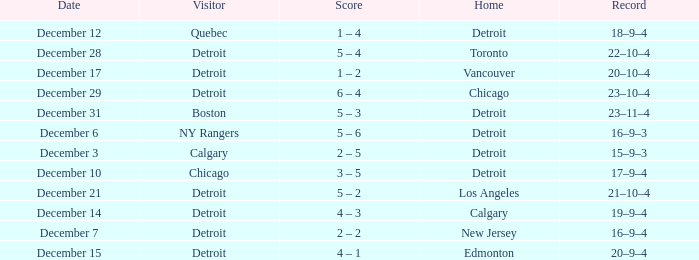What is the date for the home detroit and visitor was chicago? December 10. 